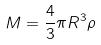<formula> <loc_0><loc_0><loc_500><loc_500>M = \frac { 4 } { 3 } \pi R ^ { 3 } \rho</formula> 